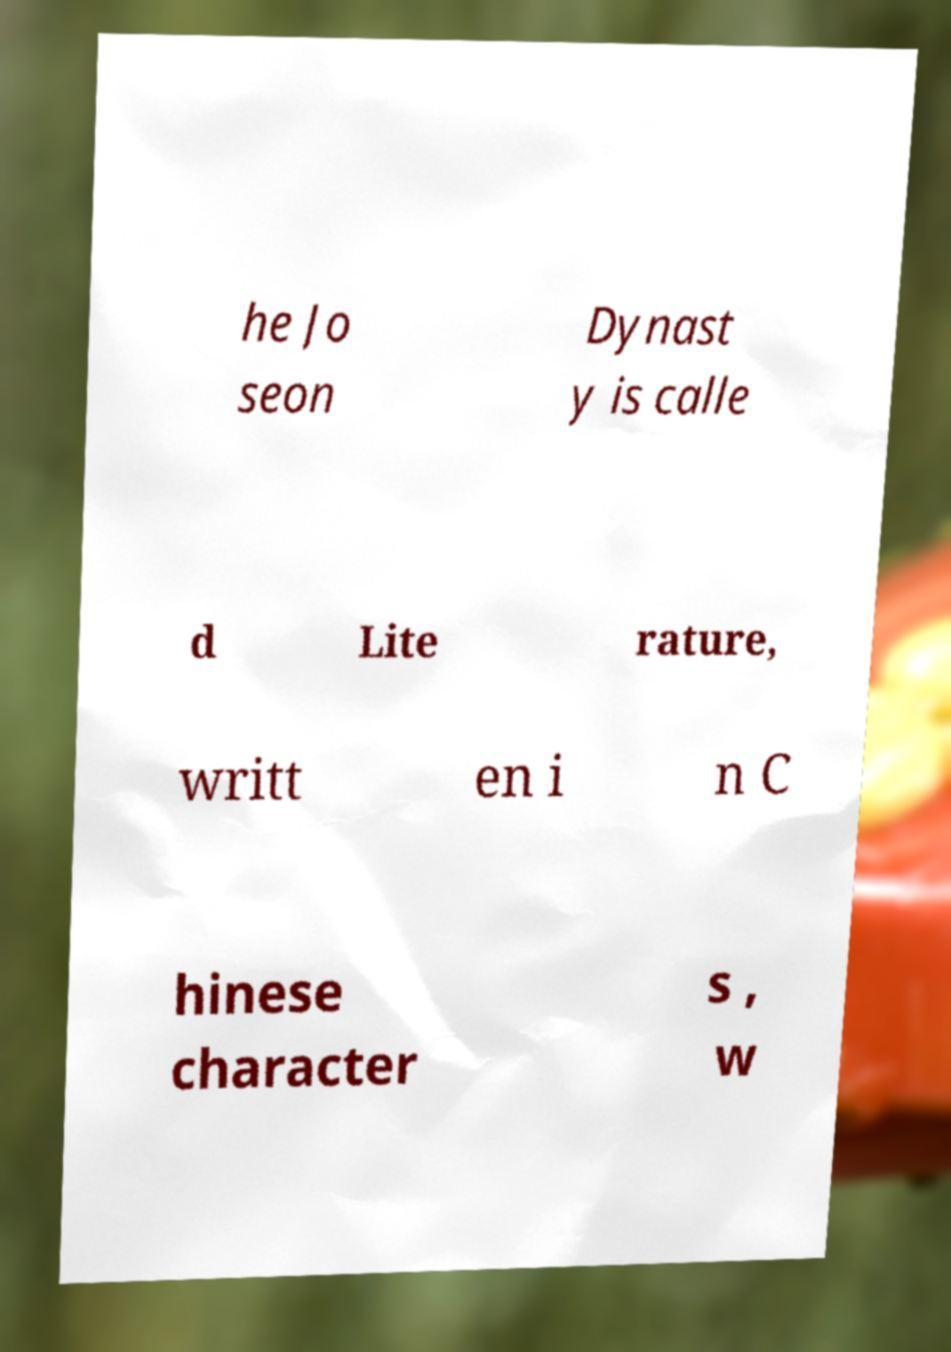Could you extract and type out the text from this image? he Jo seon Dynast y is calle d Lite rature, writt en i n C hinese character s , w 